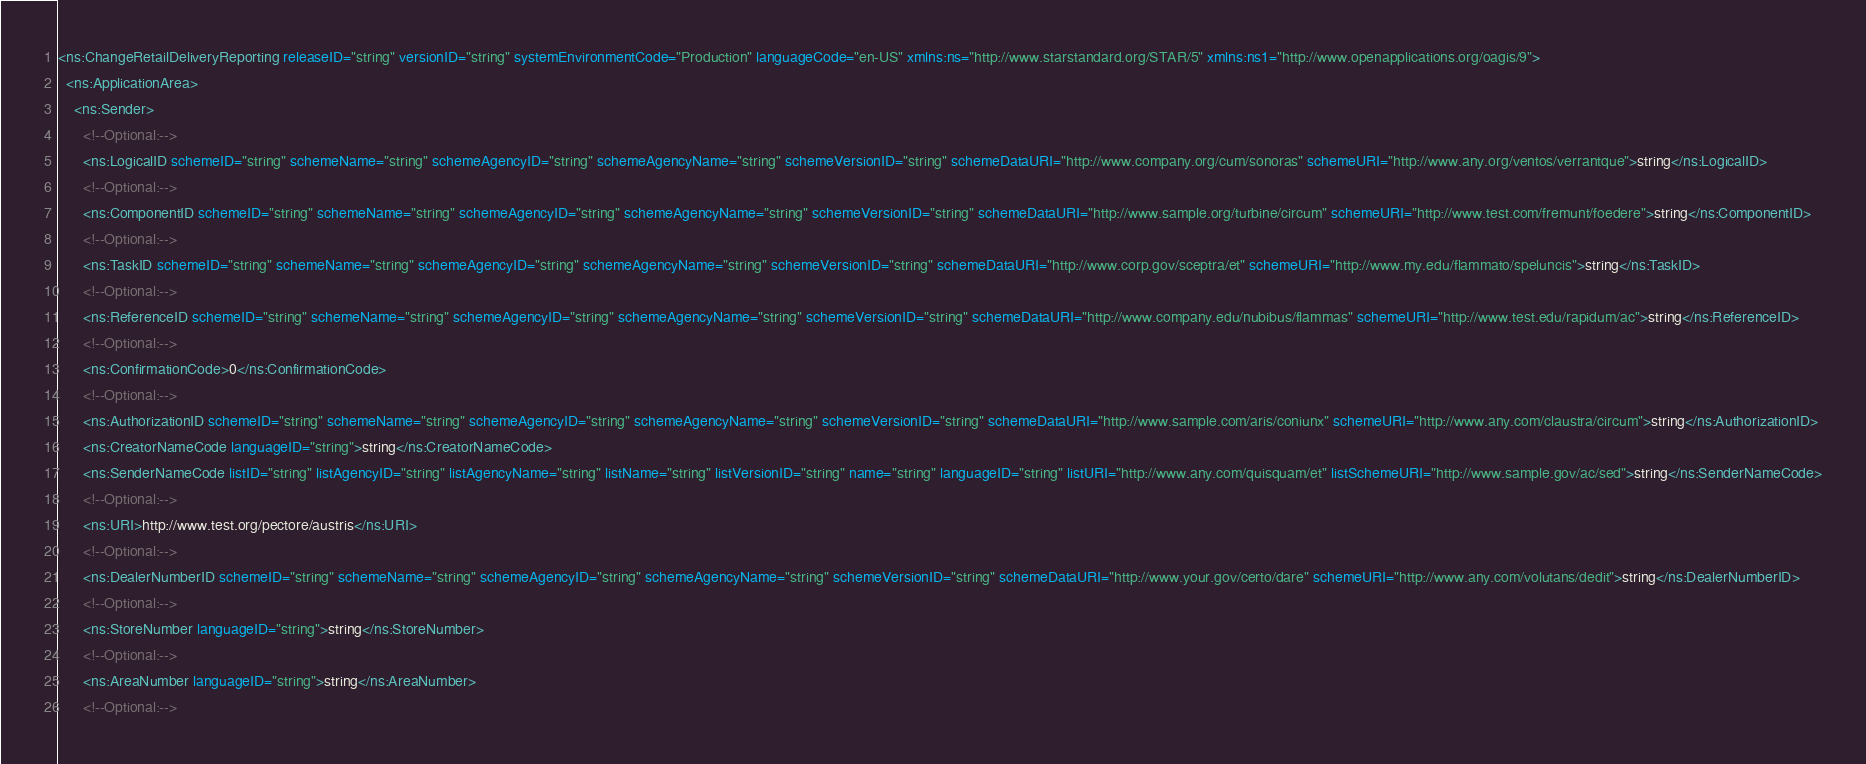<code> <loc_0><loc_0><loc_500><loc_500><_XML_><ns:ChangeRetailDeliveryReporting releaseID="string" versionID="string" systemEnvironmentCode="Production" languageCode="en-US" xmlns:ns="http://www.starstandard.org/STAR/5" xmlns:ns1="http://www.openapplications.org/oagis/9">
  <ns:ApplicationArea>
    <ns:Sender>
      <!--Optional:-->
      <ns:LogicalID schemeID="string" schemeName="string" schemeAgencyID="string" schemeAgencyName="string" schemeVersionID="string" schemeDataURI="http://www.company.org/cum/sonoras" schemeURI="http://www.any.org/ventos/verrantque">string</ns:LogicalID>
      <!--Optional:-->
      <ns:ComponentID schemeID="string" schemeName="string" schemeAgencyID="string" schemeAgencyName="string" schemeVersionID="string" schemeDataURI="http://www.sample.org/turbine/circum" schemeURI="http://www.test.com/fremunt/foedere">string</ns:ComponentID>
      <!--Optional:-->
      <ns:TaskID schemeID="string" schemeName="string" schemeAgencyID="string" schemeAgencyName="string" schemeVersionID="string" schemeDataURI="http://www.corp.gov/sceptra/et" schemeURI="http://www.my.edu/flammato/speluncis">string</ns:TaskID>
      <!--Optional:-->
      <ns:ReferenceID schemeID="string" schemeName="string" schemeAgencyID="string" schemeAgencyName="string" schemeVersionID="string" schemeDataURI="http://www.company.edu/nubibus/flammas" schemeURI="http://www.test.edu/rapidum/ac">string</ns:ReferenceID>
      <!--Optional:-->
      <ns:ConfirmationCode>0</ns:ConfirmationCode>
      <!--Optional:-->
      <ns:AuthorizationID schemeID="string" schemeName="string" schemeAgencyID="string" schemeAgencyName="string" schemeVersionID="string" schemeDataURI="http://www.sample.com/aris/coniunx" schemeURI="http://www.any.com/claustra/circum">string</ns:AuthorizationID>
      <ns:CreatorNameCode languageID="string">string</ns:CreatorNameCode>
      <ns:SenderNameCode listID="string" listAgencyID="string" listAgencyName="string" listName="string" listVersionID="string" name="string" languageID="string" listURI="http://www.any.com/quisquam/et" listSchemeURI="http://www.sample.gov/ac/sed">string</ns:SenderNameCode>
      <!--Optional:-->
      <ns:URI>http://www.test.org/pectore/austris</ns:URI>
      <!--Optional:-->
      <ns:DealerNumberID schemeID="string" schemeName="string" schemeAgencyID="string" schemeAgencyName="string" schemeVersionID="string" schemeDataURI="http://www.your.gov/certo/dare" schemeURI="http://www.any.com/volutans/dedit">string</ns:DealerNumberID>
      <!--Optional:-->
      <ns:StoreNumber languageID="string">string</ns:StoreNumber>
      <!--Optional:-->
      <ns:AreaNumber languageID="string">string</ns:AreaNumber>
      <!--Optional:--></code> 